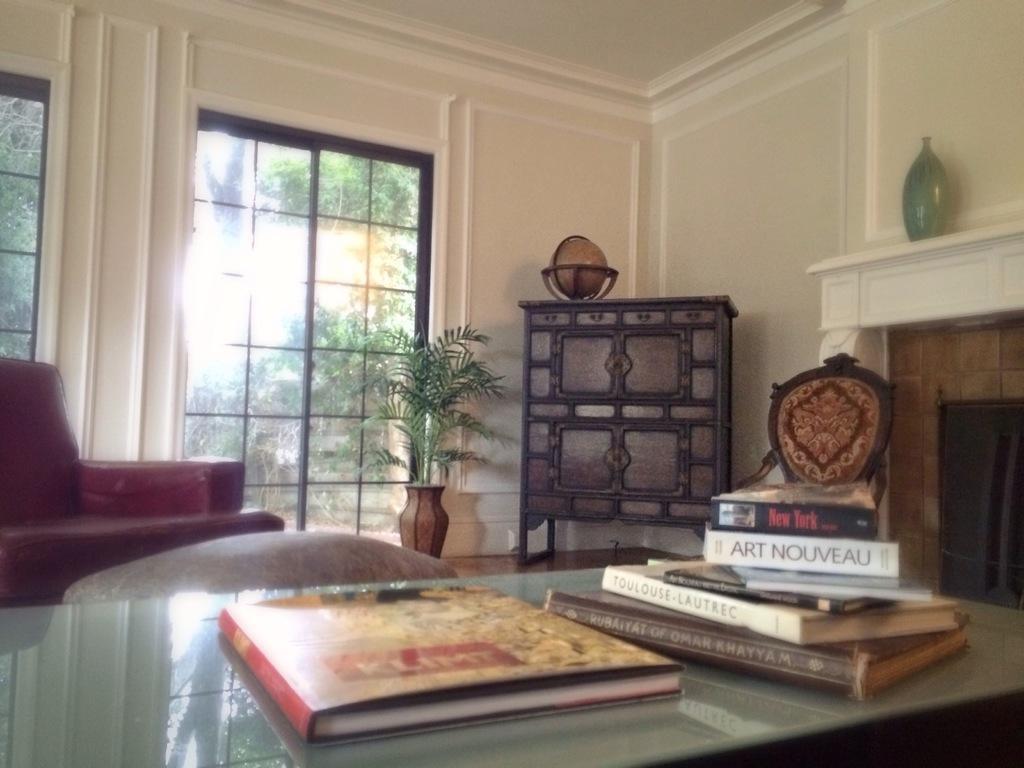Please provide a concise description of this image. This is a picture taken in a home, this is a table on the table there is a book. In front of the table there is a red color chair, flower pot, glass window and a wall. 